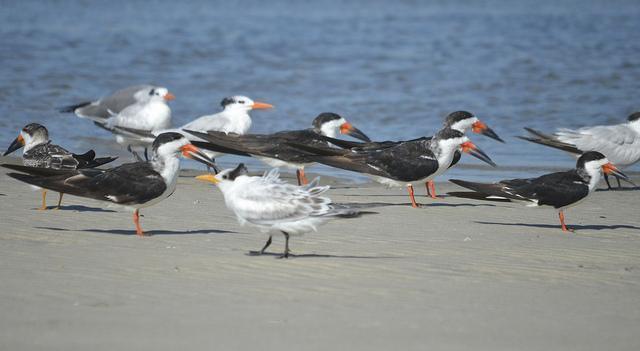How many birds are visible?
Give a very brief answer. 9. 